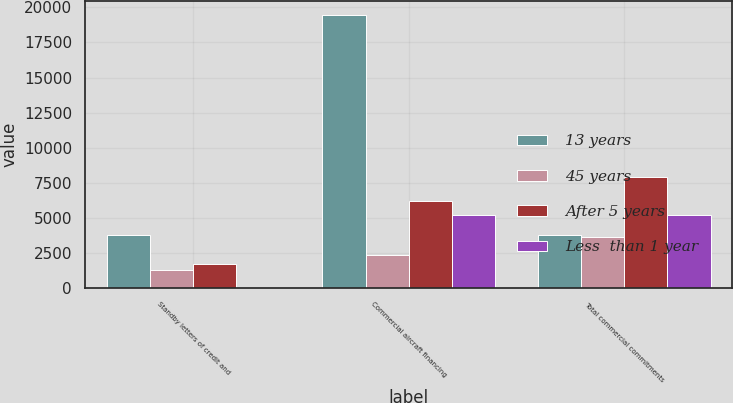<chart> <loc_0><loc_0><loc_500><loc_500><stacked_bar_chart><ecel><fcel>Standby letters of credit and<fcel>Commercial aircraft financing<fcel>Total commercial commitments<nl><fcel>13 years<fcel>3761<fcel>19462<fcel>3761<nl><fcel>45 years<fcel>1274<fcel>2331<fcel>3605<nl><fcel>After 5 years<fcel>1703<fcel>6216<fcel>7919<nl><fcel>Less  than 1 year<fcel>1<fcel>5189<fcel>5190<nl></chart> 